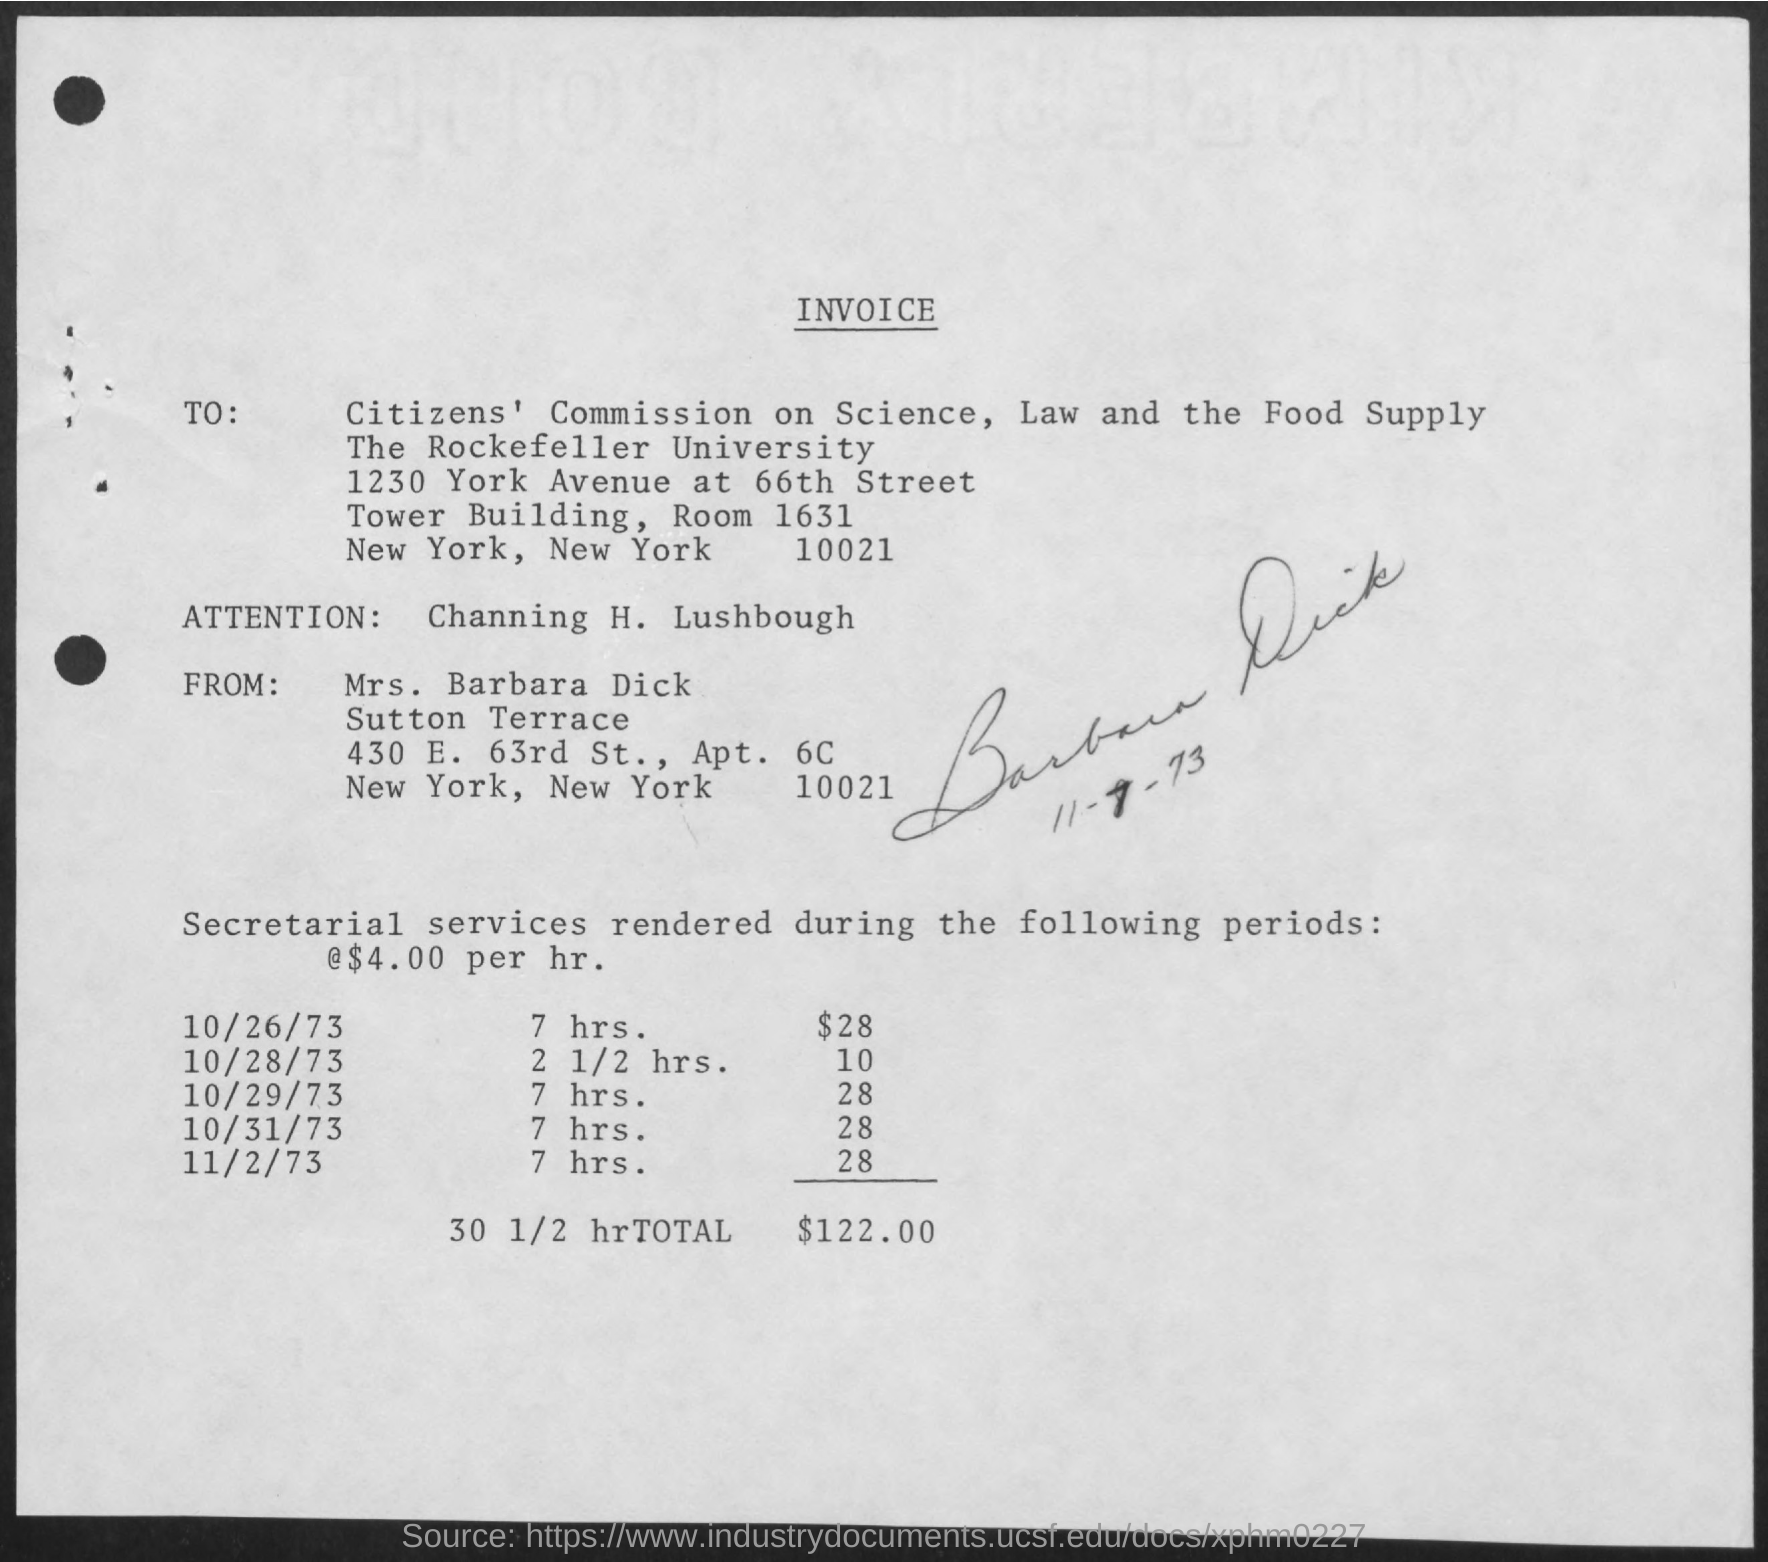Indicate a few pertinent items in this graphic. The total secretarial service amount rendered during the period was $122.00. The invoice indicates that a total of 30 1/2 hours of work were provided. On October 28, 1973, the lowest secretarial service was rendered. The invoice is being raised by Mrs. Barbara Dick. 